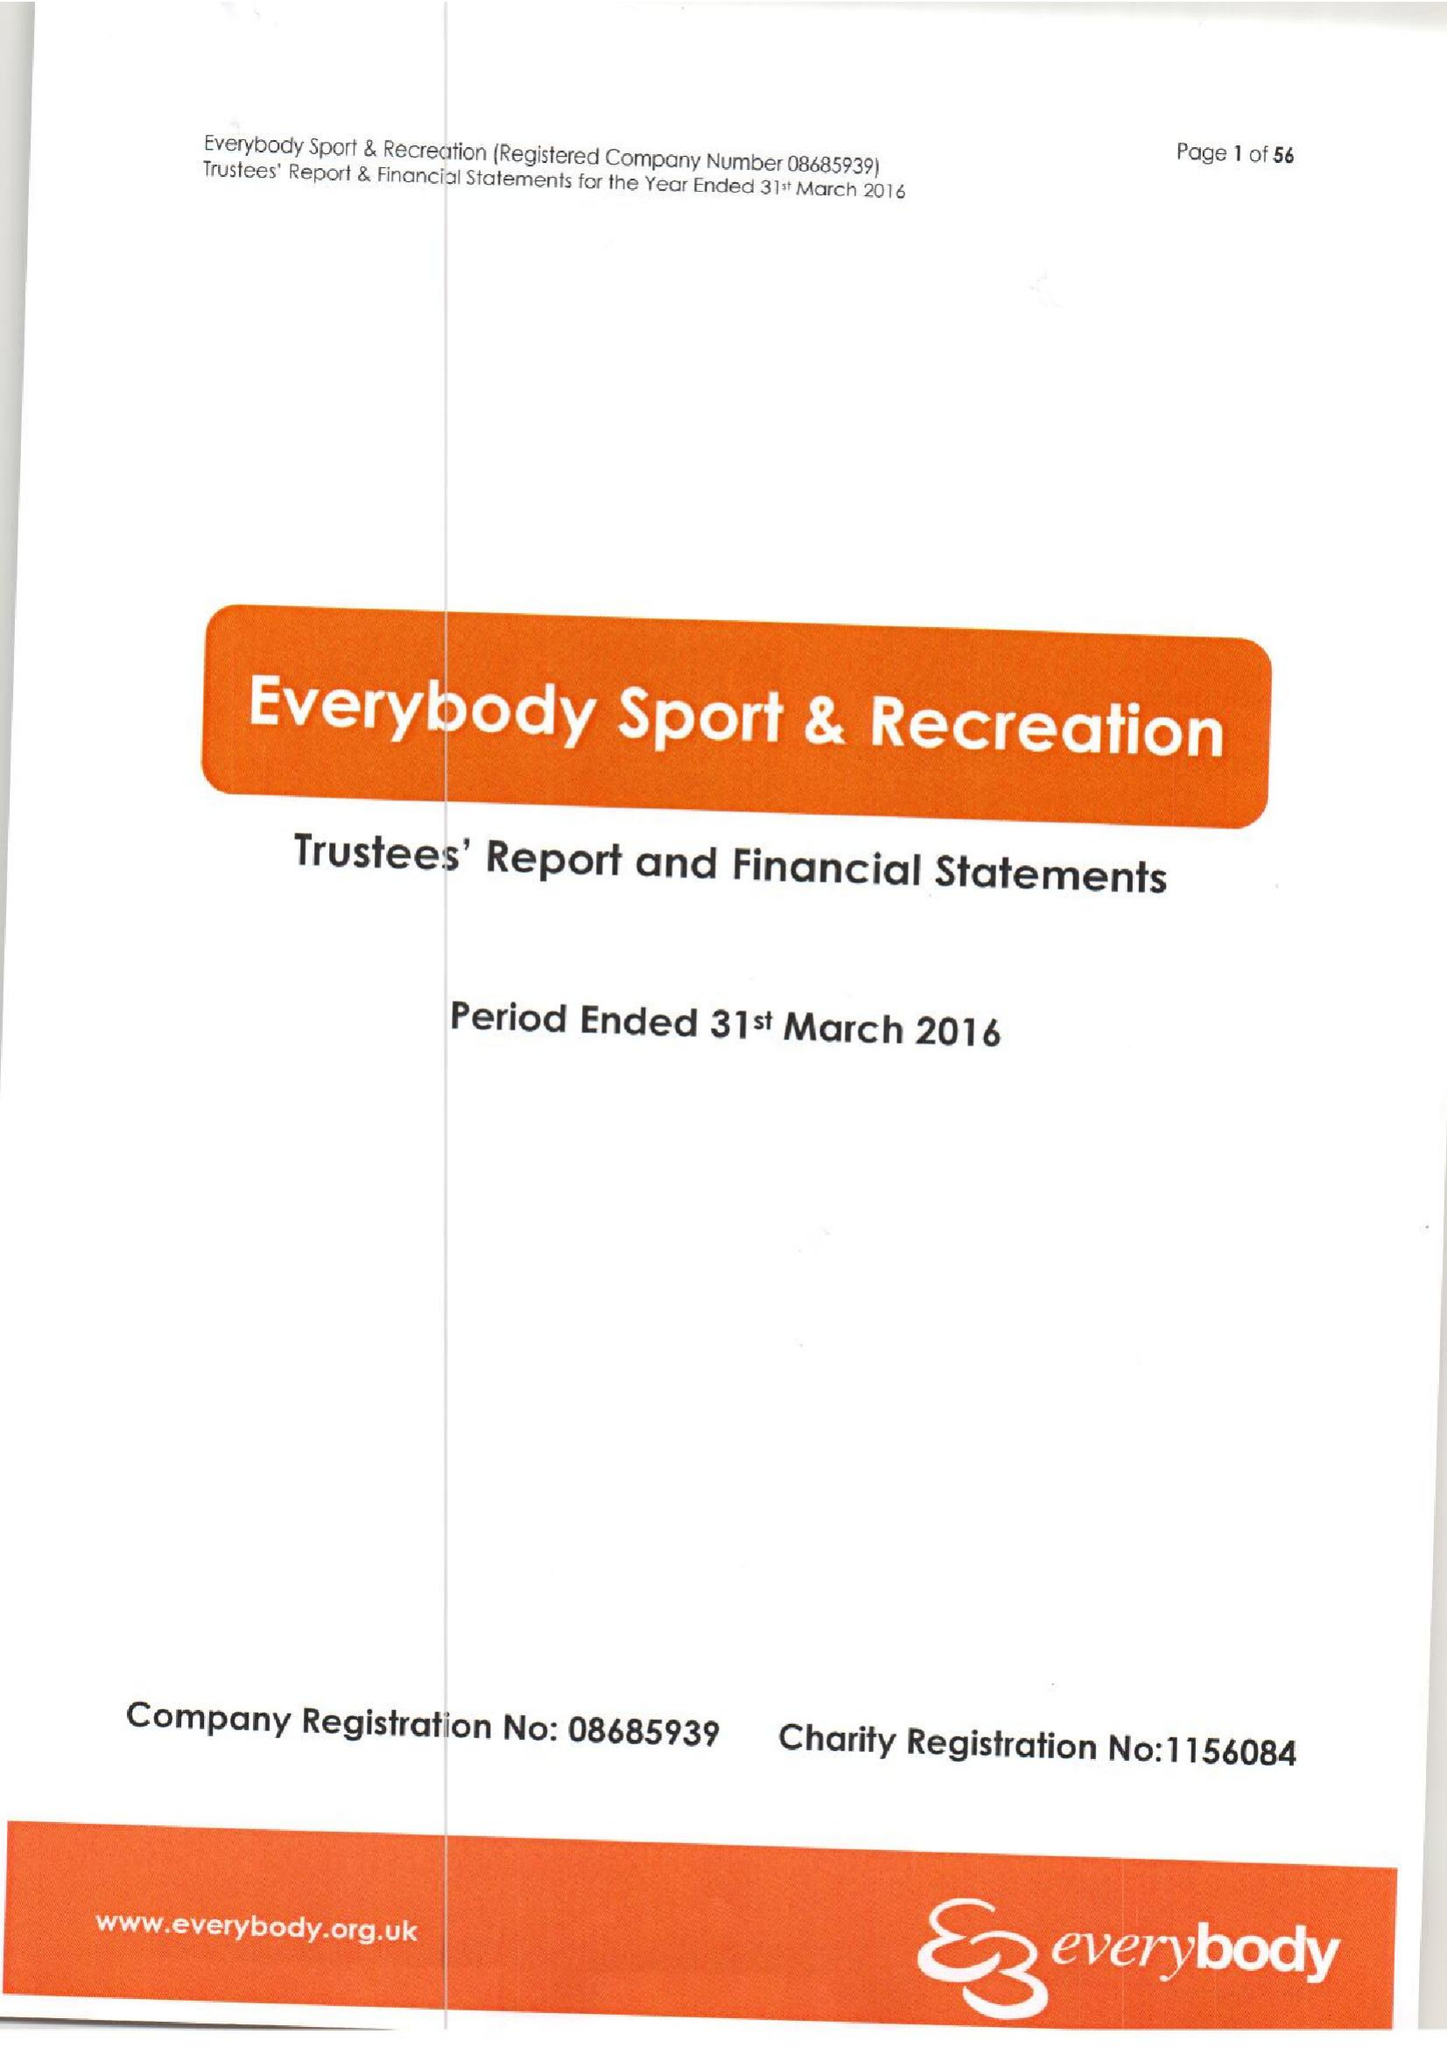What is the value for the report_date?
Answer the question using a single word or phrase. 2016-03-31 